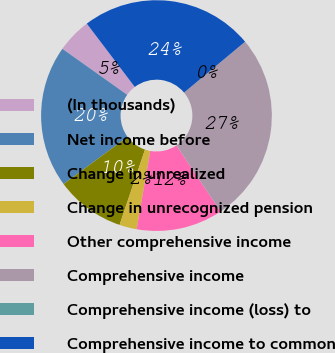<chart> <loc_0><loc_0><loc_500><loc_500><pie_chart><fcel>(In thousands)<fcel>Net income before<fcel>Change in unrealized<fcel>Change in unrecognized pension<fcel>Other comprehensive income<fcel>Comprehensive income<fcel>Comprehensive income (loss) to<fcel>Comprehensive income to common<nl><fcel>4.86%<fcel>19.93%<fcel>9.71%<fcel>2.43%<fcel>12.13%<fcel>26.68%<fcel>0.0%<fcel>24.26%<nl></chart> 